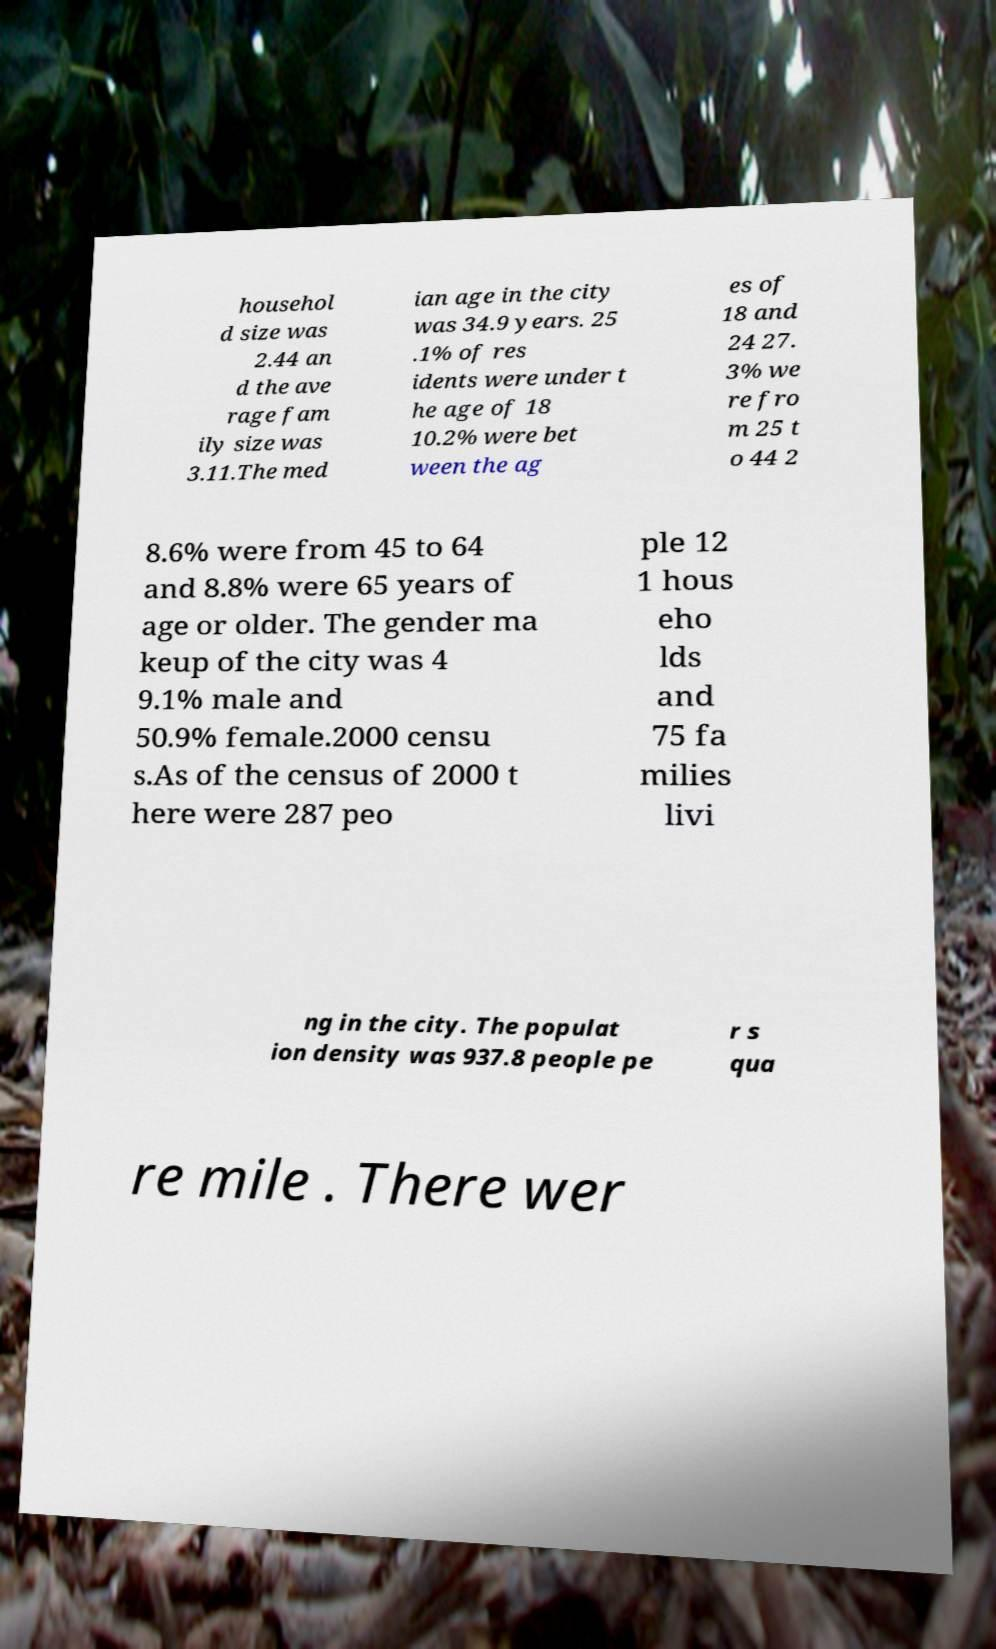Please identify and transcribe the text found in this image. househol d size was 2.44 an d the ave rage fam ily size was 3.11.The med ian age in the city was 34.9 years. 25 .1% of res idents were under t he age of 18 10.2% were bet ween the ag es of 18 and 24 27. 3% we re fro m 25 t o 44 2 8.6% were from 45 to 64 and 8.8% were 65 years of age or older. The gender ma keup of the city was 4 9.1% male and 50.9% female.2000 censu s.As of the census of 2000 t here were 287 peo ple 12 1 hous eho lds and 75 fa milies livi ng in the city. The populat ion density was 937.8 people pe r s qua re mile . There wer 